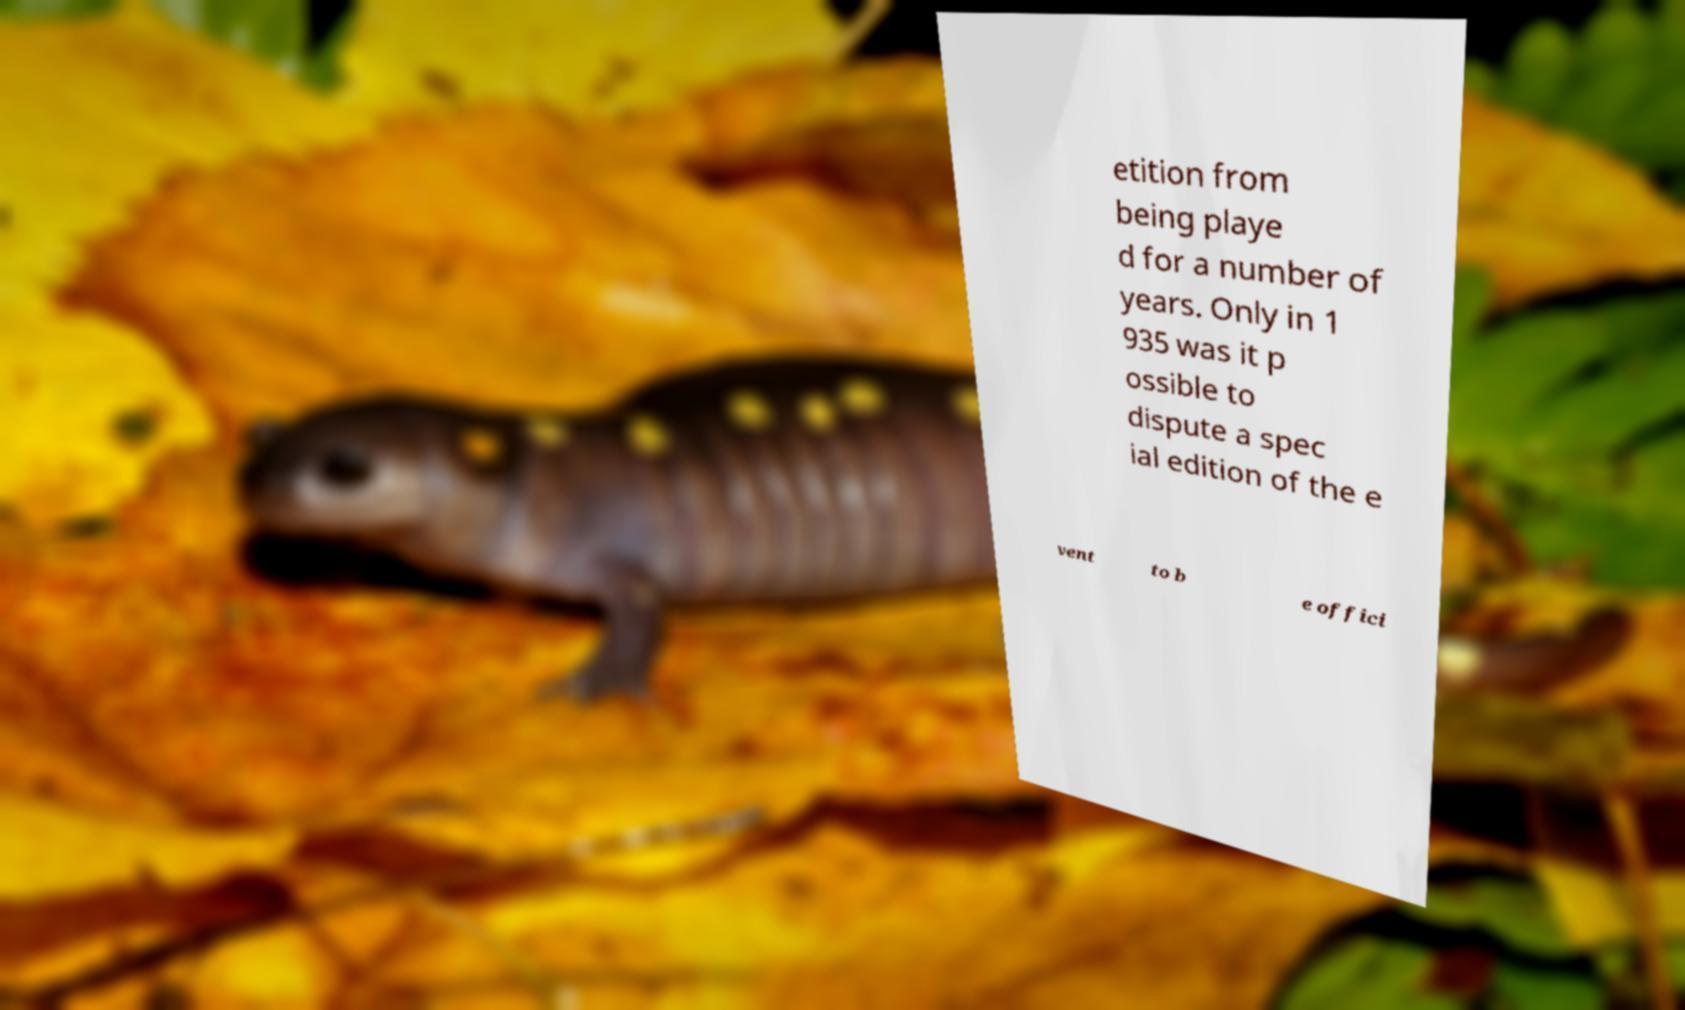What messages or text are displayed in this image? I need them in a readable, typed format. etition from being playe d for a number of years. Only in 1 935 was it p ossible to dispute a spec ial edition of the e vent to b e offici 